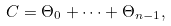<formula> <loc_0><loc_0><loc_500><loc_500>C = \Theta _ { 0 } + \cdots + \Theta _ { n - 1 } ,</formula> 